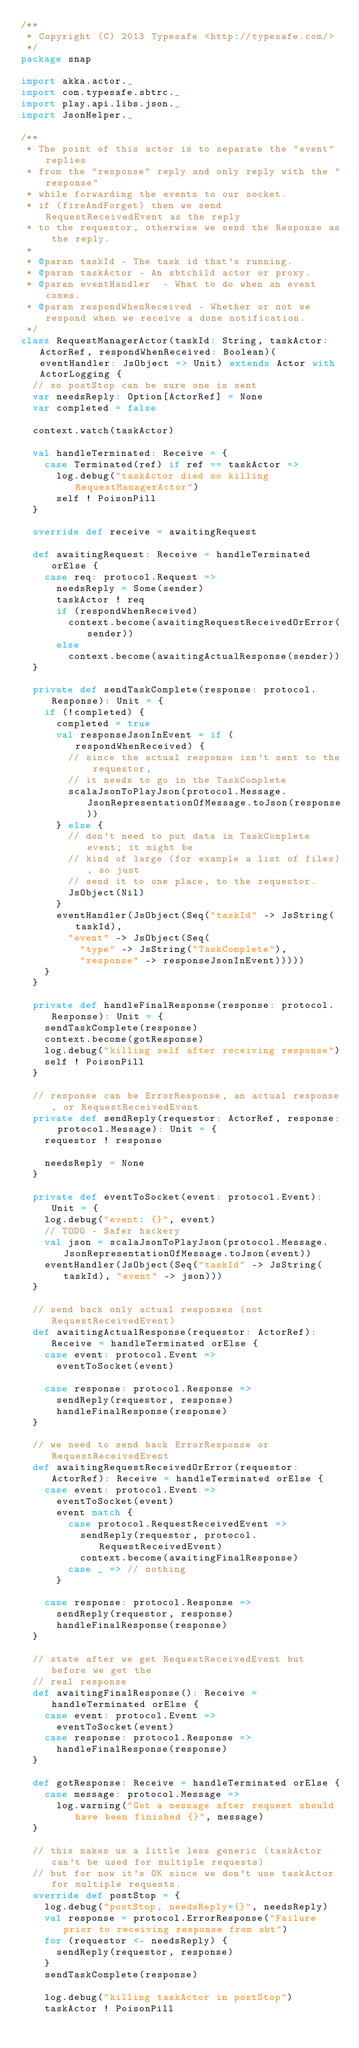<code> <loc_0><loc_0><loc_500><loc_500><_Scala_>/**
 * Copyright (C) 2013 Typesafe <http://typesafe.com/>
 */
package snap

import akka.actor._
import com.typesafe.sbtrc._
import play.api.libs.json._
import JsonHelper._

/**
 * The point of this actor is to separate the "event" replies
 * from the "response" reply and only reply with the "response"
 * while forwarding the events to our socket.
 * if (fireAndForget) then we send RequestReceivedEvent as the reply
 * to the requestor, otherwise we send the Response as the reply.
 *
 * @param taskId - The task id that's running.
 * @param taskActor - An sbtchild actor or proxy.
 * @param eventHandler  - What to do when an event comes.
 * @param respondWhenReceived - Whether or not we respond when we receive a done notification.
 */
class RequestManagerActor(taskId: String, taskActor: ActorRef, respondWhenReceived: Boolean)(eventHandler: JsObject => Unit) extends Actor with ActorLogging {
  // so postStop can be sure one is sent
  var needsReply: Option[ActorRef] = None
  var completed = false

  context.watch(taskActor)

  val handleTerminated: Receive = {
    case Terminated(ref) if ref == taskActor =>
      log.debug("taskActor died so killing RequestManagerActor")
      self ! PoisonPill
  }

  override def receive = awaitingRequest

  def awaitingRequest: Receive = handleTerminated orElse {
    case req: protocol.Request =>
      needsReply = Some(sender)
      taskActor ! req
      if (respondWhenReceived)
        context.become(awaitingRequestReceivedOrError(sender))
      else
        context.become(awaitingActualResponse(sender))
  }

  private def sendTaskComplete(response: protocol.Response): Unit = {
    if (!completed) {
      completed = true
      val responseJsonInEvent = if (respondWhenReceived) {
        // since the actual response isn't sent to the requestor,
        // it needs to go in the TaskComplete
        scalaJsonToPlayJson(protocol.Message.JsonRepresentationOfMessage.toJson(response))
      } else {
        // don't need to put data in TaskComplete event; it might be
        // kind of large (for example a list of files), so just
        // send it to one place, to the requestor.
        JsObject(Nil)
      }
      eventHandler(JsObject(Seq("taskId" -> JsString(taskId),
        "event" -> JsObject(Seq(
          "type" -> JsString("TaskComplete"),
          "response" -> responseJsonInEvent)))))
    }
  }

  private def handleFinalResponse(response: protocol.Response): Unit = {
    sendTaskComplete(response)
    context.become(gotResponse)
    log.debug("killing self after receiving response")
    self ! PoisonPill
  }

  // response can be ErrorResponse, an actual response, or RequestReceivedEvent
  private def sendReply(requestor: ActorRef, response: protocol.Message): Unit = {
    requestor ! response

    needsReply = None
  }

  private def eventToSocket(event: protocol.Event): Unit = {
    log.debug("event: {}", event)
    // TODO - Safer hackery
    val json = scalaJsonToPlayJson(protocol.Message.JsonRepresentationOfMessage.toJson(event))
    eventHandler(JsObject(Seq("taskId" -> JsString(taskId), "event" -> json)))
  }

  // send back only actual responses (not RequestReceivedEvent)
  def awaitingActualResponse(requestor: ActorRef): Receive = handleTerminated orElse {
    case event: protocol.Event =>
      eventToSocket(event)

    case response: protocol.Response =>
      sendReply(requestor, response)
      handleFinalResponse(response)
  }

  // we need to send back ErrorResponse or RequestReceivedEvent
  def awaitingRequestReceivedOrError(requestor: ActorRef): Receive = handleTerminated orElse {
    case event: protocol.Event =>
      eventToSocket(event)
      event match {
        case protocol.RequestReceivedEvent =>
          sendReply(requestor, protocol.RequestReceivedEvent)
          context.become(awaitingFinalResponse)
        case _ => // nothing
      }

    case response: protocol.Response =>
      sendReply(requestor, response)
      handleFinalResponse(response)
  }

  // state after we get RequestReceivedEvent but before we get the
  // real response
  def awaitingFinalResponse(): Receive = handleTerminated orElse {
    case event: protocol.Event =>
      eventToSocket(event)
    case response: protocol.Response =>
      handleFinalResponse(response)
  }

  def gotResponse: Receive = handleTerminated orElse {
    case message: protocol.Message =>
      log.warning("Got a message after request should have been finished {}", message)
  }

  // this makes us a little less generic (taskActor can't be used for multiple requests)
  // but for now it's OK since we don't use taskActor for multiple requests.
  override def postStop = {
    log.debug("postStop, needsReply={}", needsReply)
    val response = protocol.ErrorResponse("Failure prior to receiving response from sbt")
    for (requestor <- needsReply) {
      sendReply(requestor, response)
    }
    sendTaskComplete(response)

    log.debug("killing taskActor in postStop")
    taskActor ! PoisonPill</code> 